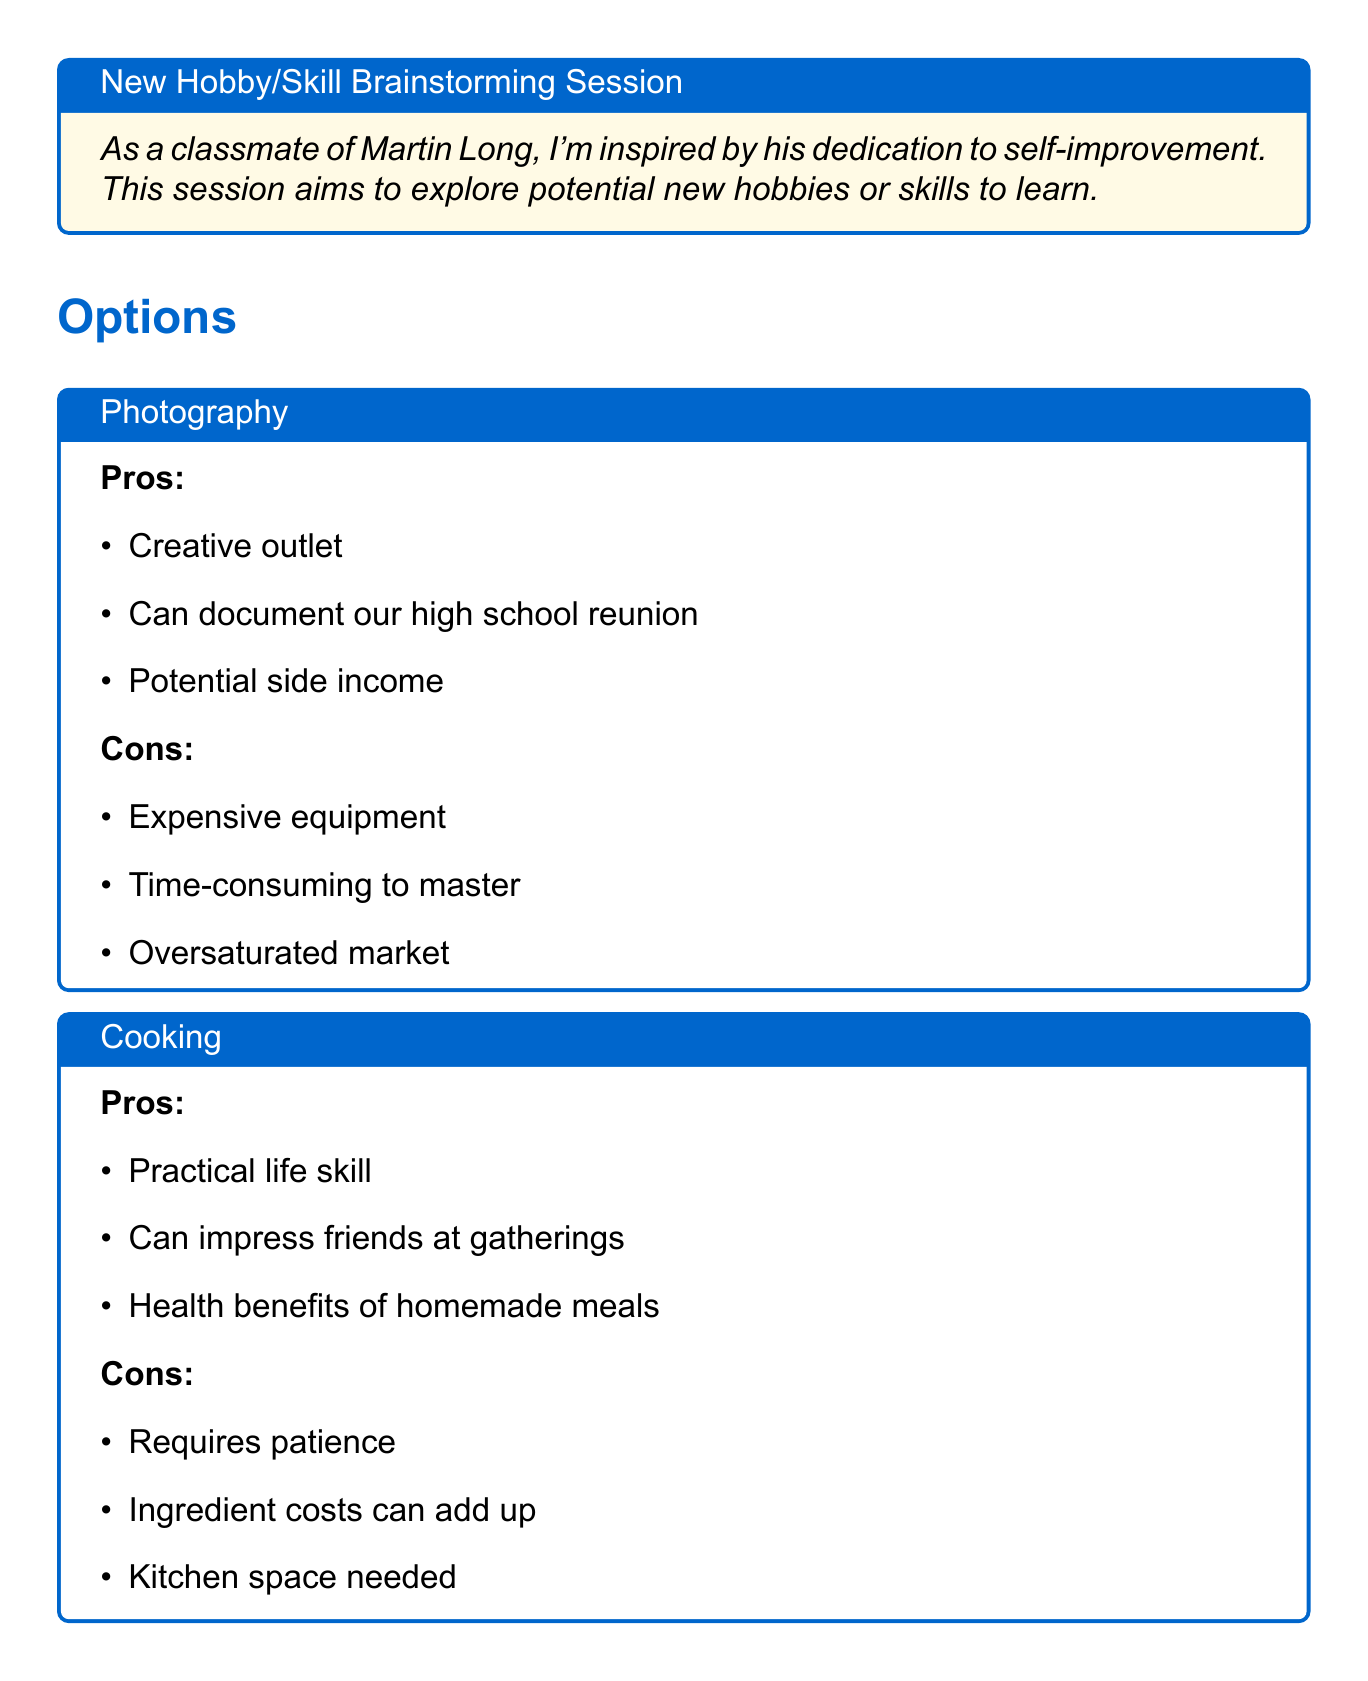What is the title of the session? The title of the session is presented at the beginning of the document and indicates the focus on new hobbies or skills.
Answer: New Hobby/Skill Brainstorming Session What are the pros of learning Photography? The pros of learning Photography are listed in a box, highlighting positive aspects of the hobby.
Answer: Creative outlet, Can document our high school reunion, Potential side income What is one con of Cooking? The document includes cons for Cooking, outlining some potential challenges associated with this hobby.
Answer: Requires patience How many hobbies are listed in the options? The document provides three distinct hobbies that can be considered for the brainstorming session.
Answer: Three What benefit is associated with Learning a Musical Instrument (Guitar)? The potential benefits of Learning a Musical Instrument are detailed, focusing on its positive impacts.
Answer: Stress relief What is a key consideration mentioned in the document? The document lists considerations that influence the choice of hobby, addressing factors to evaluate before making a decision.
Answer: Time commitment required What does the conclusion emphasize? The conclusion provides a summary of the discussion, reinforcing the importance of personal connection to the hobby chosen.
Answer: Personal passion and practicality 